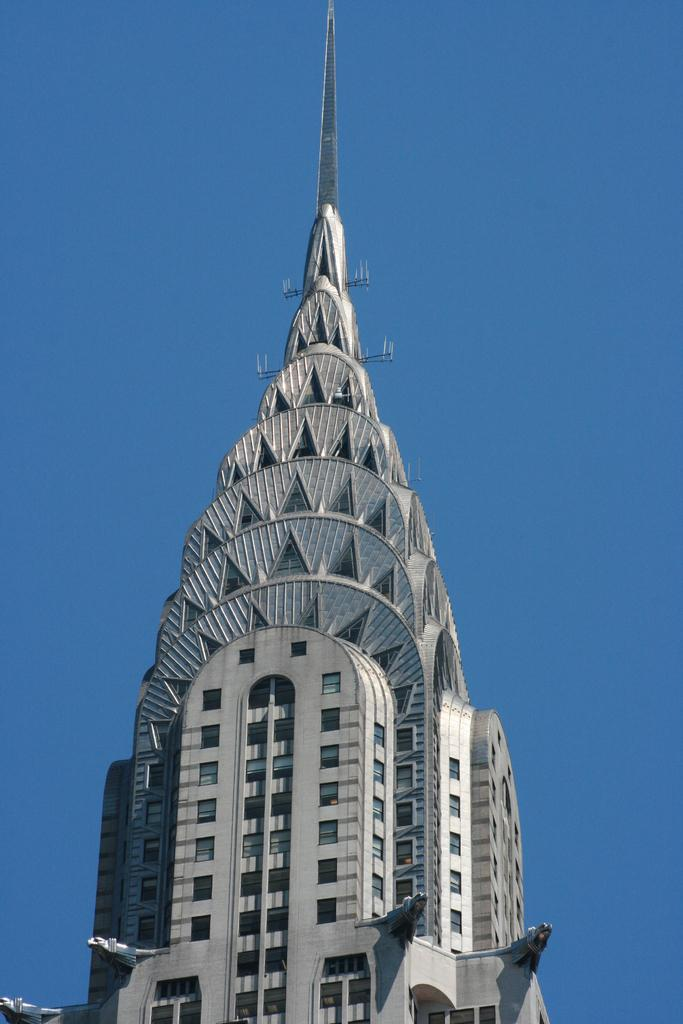What famous building can be seen in the image? The Chrysler building is visible in the image. What part of the natural environment is visible in the image? The sky is visible in the background of the image. What type of reward is being offered to the person who can change the light bulb in the image? There is no light bulb or reward mentioned in the image; it only features the Chrysler building and the sky. 